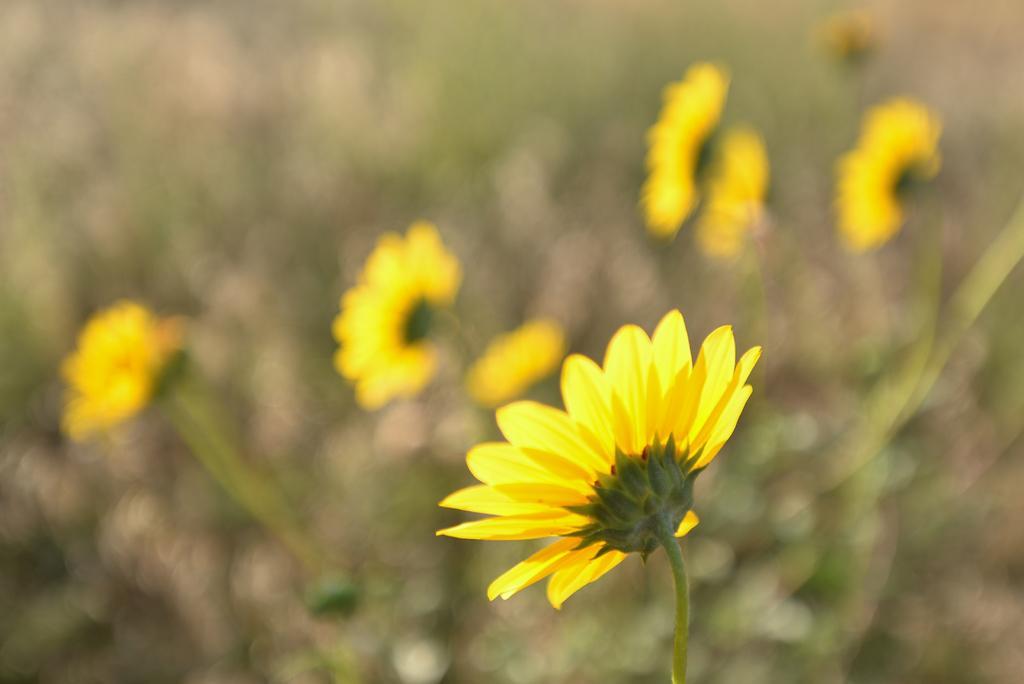In one or two sentences, can you explain what this image depicts? In this image we can see plants with flowers. In the background the image is blur. 